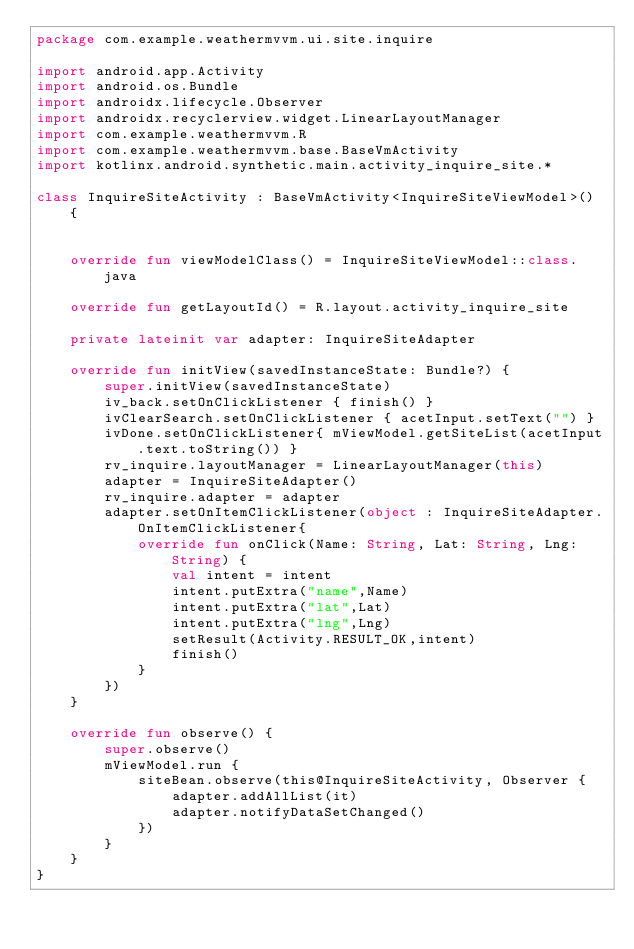Convert code to text. <code><loc_0><loc_0><loc_500><loc_500><_Kotlin_>package com.example.weathermvvm.ui.site.inquire

import android.app.Activity
import android.os.Bundle
import androidx.lifecycle.Observer
import androidx.recyclerview.widget.LinearLayoutManager
import com.example.weathermvvm.R
import com.example.weathermvvm.base.BaseVmActivity
import kotlinx.android.synthetic.main.activity_inquire_site.*

class InquireSiteActivity : BaseVmActivity<InquireSiteViewModel>() {


    override fun viewModelClass() = InquireSiteViewModel::class.java

    override fun getLayoutId() = R.layout.activity_inquire_site

    private lateinit var adapter: InquireSiteAdapter

    override fun initView(savedInstanceState: Bundle?) {
        super.initView(savedInstanceState)
        iv_back.setOnClickListener { finish() }
        ivClearSearch.setOnClickListener { acetInput.setText("") }
        ivDone.setOnClickListener{ mViewModel.getSiteList(acetInput.text.toString()) }
        rv_inquire.layoutManager = LinearLayoutManager(this)
        adapter = InquireSiteAdapter()
        rv_inquire.adapter = adapter
        adapter.setOnItemClickListener(object : InquireSiteAdapter.OnItemClickListener{
            override fun onClick(Name: String, Lat: String, Lng: String) {
                val intent = intent
                intent.putExtra("name",Name)
                intent.putExtra("lat",Lat)
                intent.putExtra("lng",Lng)
                setResult(Activity.RESULT_OK,intent)
                finish()
            }
        })
    }

    override fun observe() {
        super.observe()
        mViewModel.run {
            siteBean.observe(this@InquireSiteActivity, Observer {
                adapter.addAllList(it)
                adapter.notifyDataSetChanged()
            })
        }
    }
}</code> 